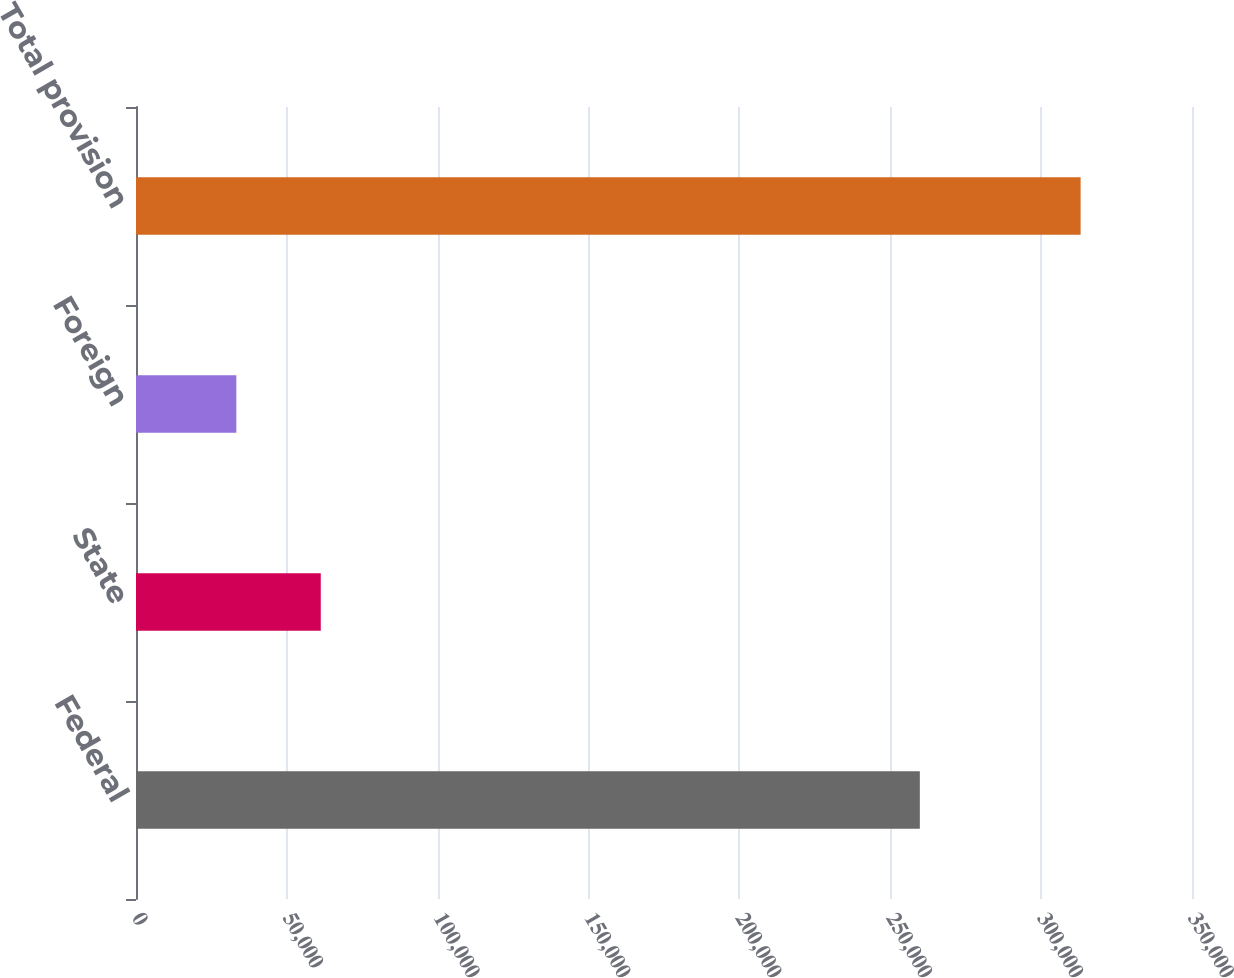<chart> <loc_0><loc_0><loc_500><loc_500><bar_chart><fcel>Federal<fcel>State<fcel>Foreign<fcel>Total provision<nl><fcel>259793<fcel>61237.7<fcel>33255<fcel>313082<nl></chart> 